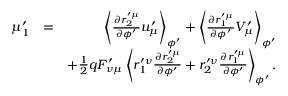Convert formula to latex. <formula><loc_0><loc_0><loc_500><loc_500>\begin{array} { r l r } { \mu _ { 1 } ^ { \prime } } & { = } & { \left \langle \frac { \partial r _ { 2 } ^ { \prime \mu } } { \partial \phi ^ { \prime } } u _ { \mu } ^ { \prime } \right \rangle _ { \phi ^ { \prime } } + \left \langle \frac { \partial r _ { 1 } ^ { \prime \mu } } { \partial \phi ^ { \prime } } V _ { \mu } ^ { \prime } \right \rangle _ { \phi ^ { \prime } } } \\ & { + \frac { 1 } { 2 } q F _ { \nu \mu } ^ { \prime } \left \langle r _ { 1 } ^ { \prime \nu } \frac { \partial r _ { 2 } ^ { \prime \mu } } { \partial \phi ^ { \prime } } + r _ { 2 } ^ { \prime \nu } \frac { \partial r _ { 1 } ^ { \prime \mu } } { \partial \phi ^ { \prime } } \right \rangle _ { \phi ^ { \prime } } . } \end{array}</formula> 